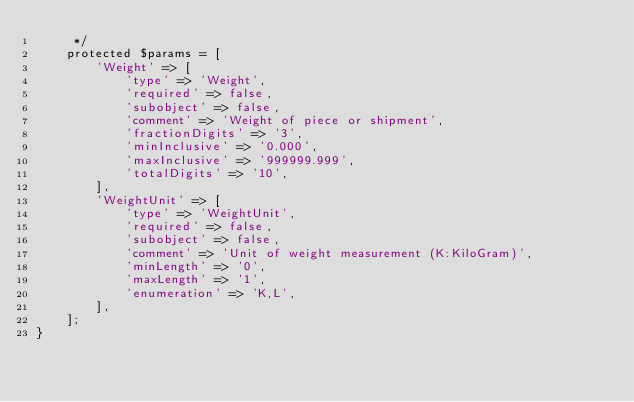<code> <loc_0><loc_0><loc_500><loc_500><_PHP_>     */
    protected $params = [
        'Weight' => [
            'type' => 'Weight',
            'required' => false,
            'subobject' => false,
            'comment' => 'Weight of piece or shipment',
            'fractionDigits' => '3',
            'minInclusive' => '0.000',
            'maxInclusive' => '999999.999',
            'totalDigits' => '10',
        ],
        'WeightUnit' => [
            'type' => 'WeightUnit',
            'required' => false,
            'subobject' => false,
            'comment' => 'Unit of weight measurement (K:KiloGram)',
            'minLength' => '0',
            'maxLength' => '1',
            'enumeration' => 'K,L',
        ],
    ];
}
</code> 